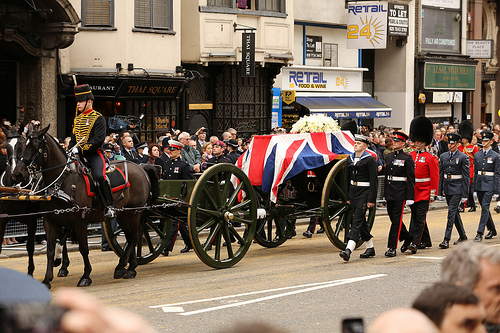Which side is the brown animal on? The brown horse is on the left side. 